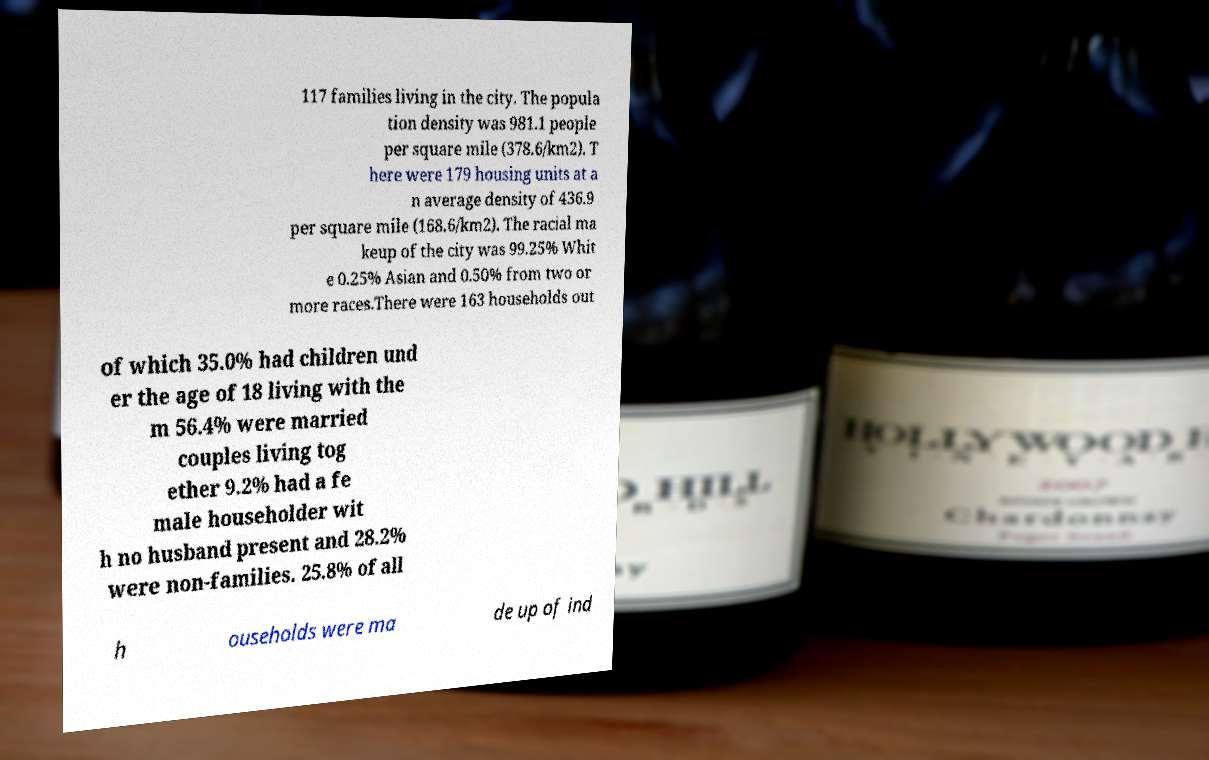Could you extract and type out the text from this image? 117 families living in the city. The popula tion density was 981.1 people per square mile (378.6/km2). T here were 179 housing units at a n average density of 436.9 per square mile (168.6/km2). The racial ma keup of the city was 99.25% Whit e 0.25% Asian and 0.50% from two or more races.There were 163 households out of which 35.0% had children und er the age of 18 living with the m 56.4% were married couples living tog ether 9.2% had a fe male householder wit h no husband present and 28.2% were non-families. 25.8% of all h ouseholds were ma de up of ind 